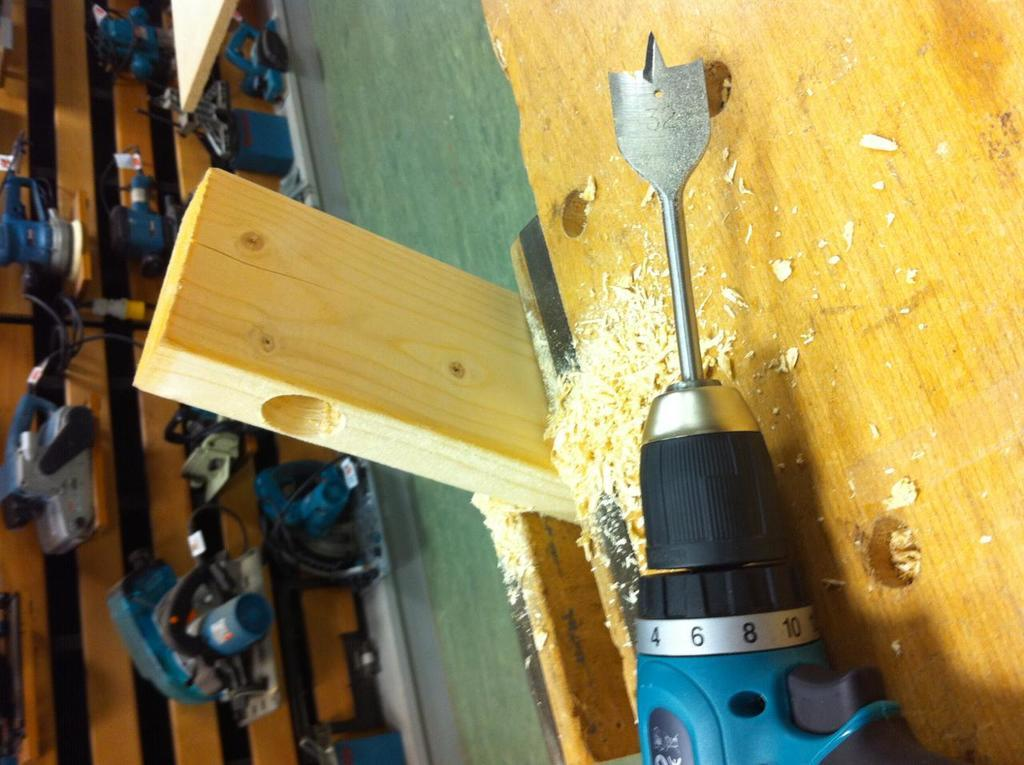What is the main object on the wooden plank in the image? There is a chopping machine on the wooden plank in the image. What is the wooden plank resting on or against in the image? The wooden plank is not resting on or against anything specific in the image. What can be seen on the wall in the image? There are machines on the wall in the image. Can you tell me how many dolls are sitting on the wooden plank in the image? There are no dolls present on the wooden plank in the image. What story is being told by the machines on the wall in the image? The machines on the wall do not tell a story; they are simply depicted as objects in the image. 